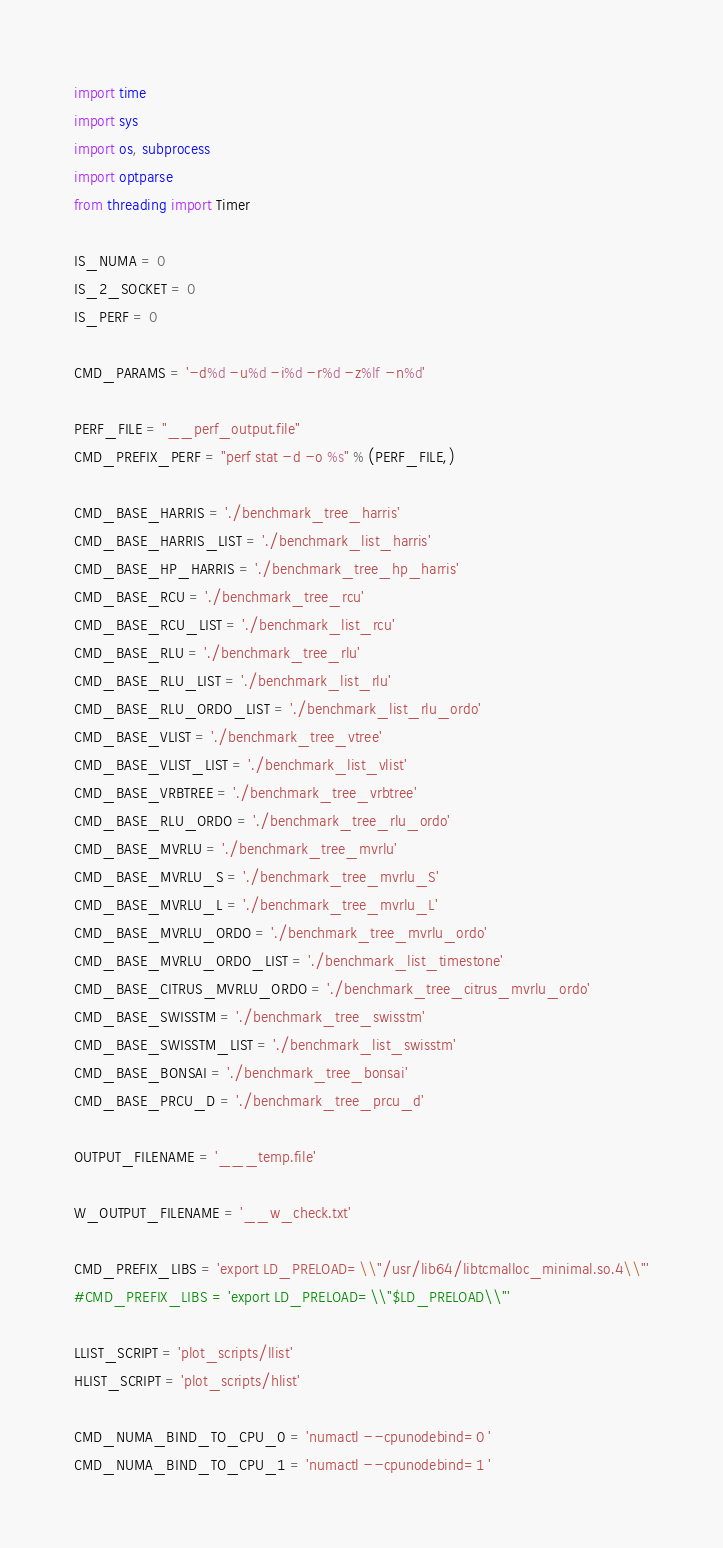Convert code to text. <code><loc_0><loc_0><loc_500><loc_500><_Python_>import time
import sys
import os, subprocess
import optparse
from threading import Timer

IS_NUMA = 0
IS_2_SOCKET = 0
IS_PERF = 0

CMD_PARAMS = '-d%d -u%d -i%d -r%d -z%lf -n%d'

PERF_FILE = "__perf_output.file"
CMD_PREFIX_PERF = "perf stat -d -o %s" % (PERF_FILE,)

CMD_BASE_HARRIS = './benchmark_tree_harris'
CMD_BASE_HARRIS_LIST = './benchmark_list_harris'
CMD_BASE_HP_HARRIS = './benchmark_tree_hp_harris'
CMD_BASE_RCU = './benchmark_tree_rcu'
CMD_BASE_RCU_LIST = './benchmark_list_rcu'
CMD_BASE_RLU = './benchmark_tree_rlu'
CMD_BASE_RLU_LIST = './benchmark_list_rlu'
CMD_BASE_RLU_ORDO_LIST = './benchmark_list_rlu_ordo'
CMD_BASE_VLIST = './benchmark_tree_vtree'
CMD_BASE_VLIST_LIST = './benchmark_list_vlist'
CMD_BASE_VRBTREE = './benchmark_tree_vrbtree'
CMD_BASE_RLU_ORDO = './benchmark_tree_rlu_ordo'
CMD_BASE_MVRLU = './benchmark_tree_mvrlu'
CMD_BASE_MVRLU_S = './benchmark_tree_mvrlu_S'
CMD_BASE_MVRLU_L = './benchmark_tree_mvrlu_L'
CMD_BASE_MVRLU_ORDO = './benchmark_tree_mvrlu_ordo'
CMD_BASE_MVRLU_ORDO_LIST = './benchmark_list_timestone'
CMD_BASE_CITRUS_MVRLU_ORDO = './benchmark_tree_citrus_mvrlu_ordo'
CMD_BASE_SWISSTM = './benchmark_tree_swisstm'
CMD_BASE_SWISSTM_LIST = './benchmark_list_swisstm'
CMD_BASE_BONSAI = './benchmark_tree_bonsai'
CMD_BASE_PRCU_D = './benchmark_tree_prcu_d'

OUTPUT_FILENAME = '___temp.file'

W_OUTPUT_FILENAME = '__w_check.txt'

CMD_PREFIX_LIBS = 'export LD_PRELOAD=\\"/usr/lib64/libtcmalloc_minimal.so.4\\"'
#CMD_PREFIX_LIBS = 'export LD_PRELOAD=\\"$LD_PRELOAD\\"'

LLIST_SCRIPT = 'plot_scripts/llist'
HLIST_SCRIPT = 'plot_scripts/hlist'

CMD_NUMA_BIND_TO_CPU_0 = 'numactl --cpunodebind=0 '
CMD_NUMA_BIND_TO_CPU_1 = 'numactl --cpunodebind=1 '</code> 